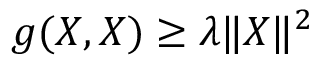<formula> <loc_0><loc_0><loc_500><loc_500>g ( X , X ) \geq \lambda \| X \| ^ { 2 }</formula> 